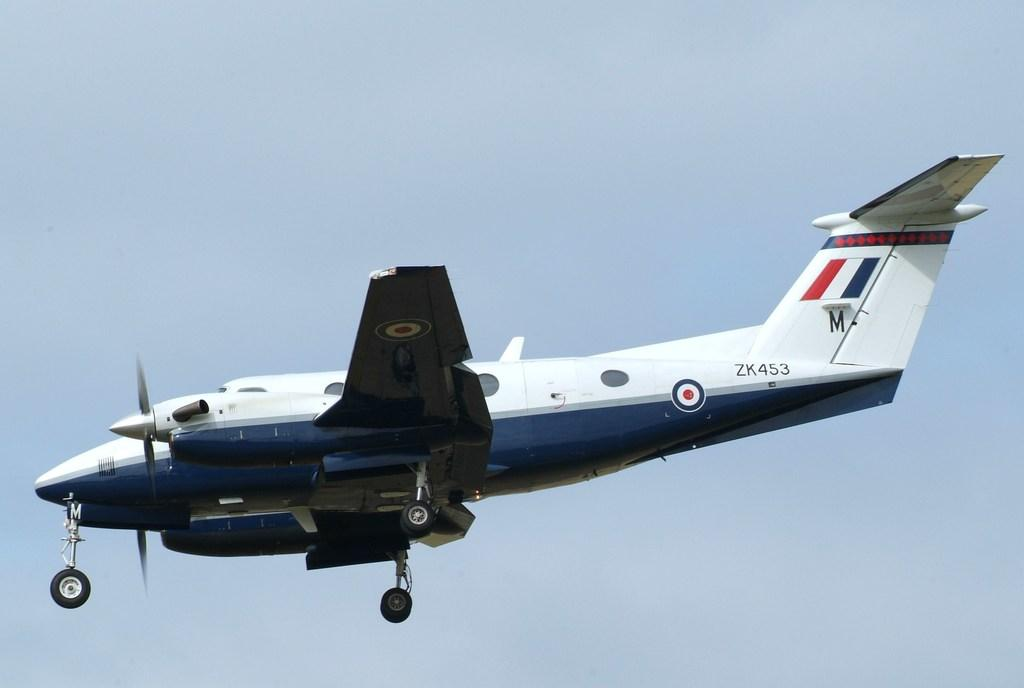<image>
Provide a brief description of the given image. A small aircraft with the numbers 453 towards the tail 